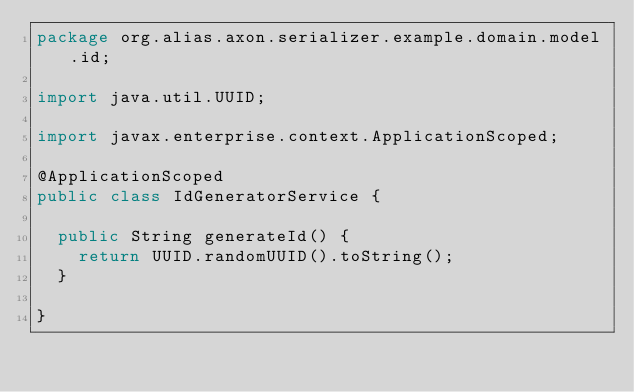Convert code to text. <code><loc_0><loc_0><loc_500><loc_500><_Java_>package org.alias.axon.serializer.example.domain.model.id;

import java.util.UUID;

import javax.enterprise.context.ApplicationScoped;

@ApplicationScoped
public class IdGeneratorService {

	public String generateId() {
		return UUID.randomUUID().toString();
	}

}
</code> 